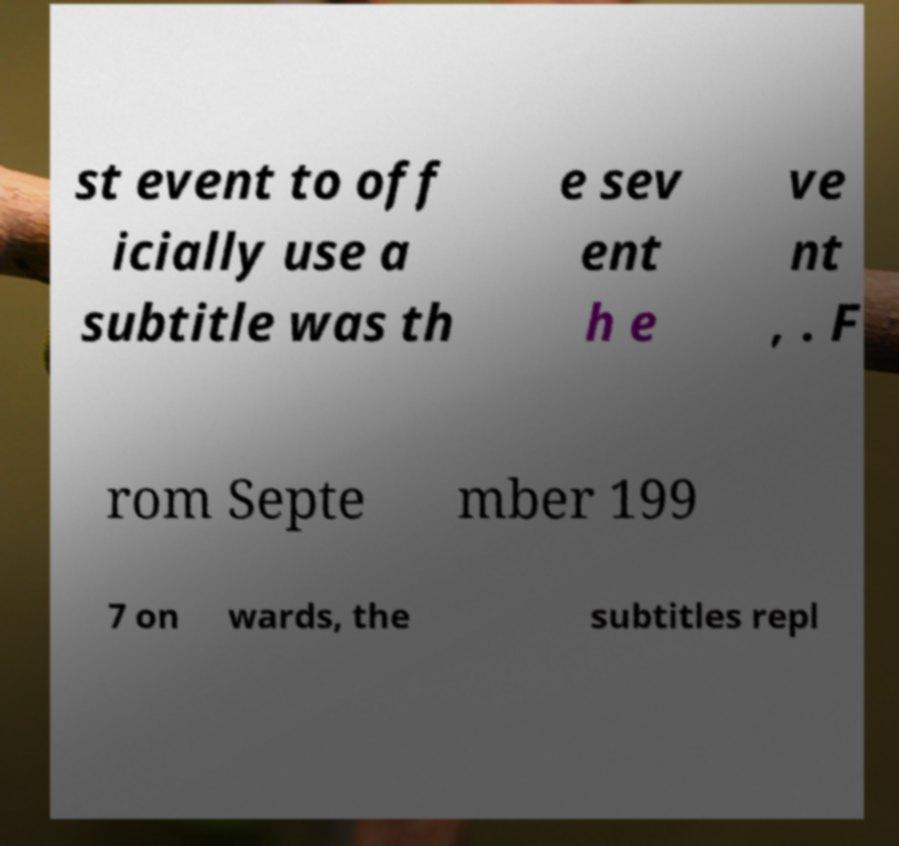What messages or text are displayed in this image? I need them in a readable, typed format. st event to off icially use a subtitle was th e sev ent h e ve nt , . F rom Septe mber 199 7 on wards, the subtitles repl 